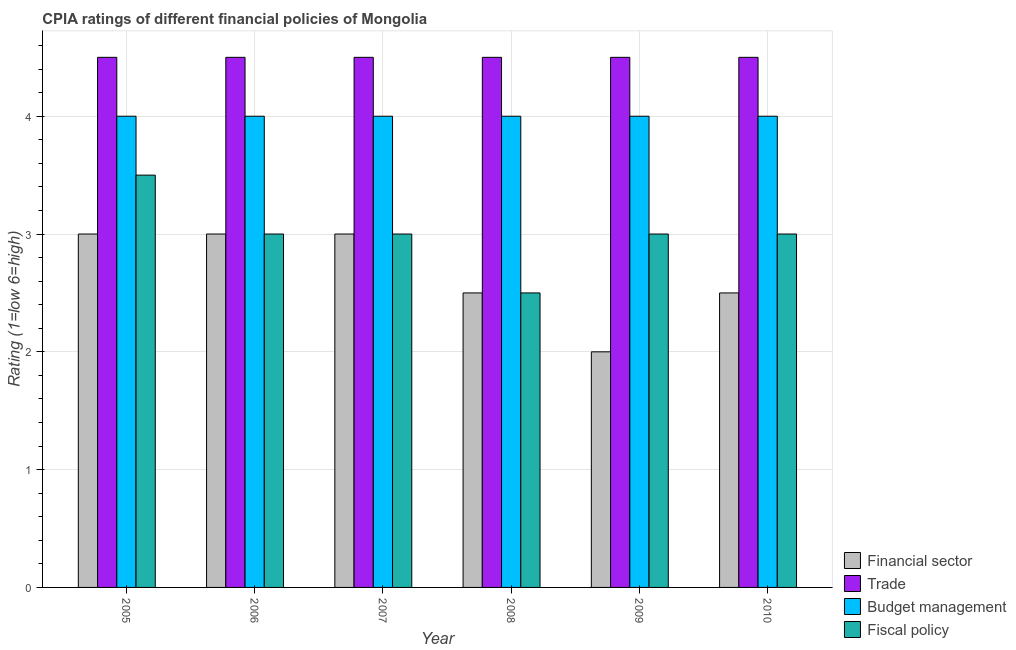How many different coloured bars are there?
Offer a terse response. 4. How many bars are there on the 1st tick from the left?
Give a very brief answer. 4. How many bars are there on the 6th tick from the right?
Offer a very short reply. 4. What is the cpia rating of budget management in 2009?
Ensure brevity in your answer.  4. What is the difference between the cpia rating of budget management in 2010 and the cpia rating of fiscal policy in 2009?
Offer a very short reply. 0. What is the average cpia rating of trade per year?
Your answer should be very brief. 4.5. In the year 2007, what is the difference between the cpia rating of fiscal policy and cpia rating of trade?
Provide a succinct answer. 0. What is the ratio of the cpia rating of fiscal policy in 2005 to that in 2010?
Make the answer very short. 1.17. Is the difference between the cpia rating of financial sector in 2008 and 2010 greater than the difference between the cpia rating of trade in 2008 and 2010?
Make the answer very short. No. In how many years, is the cpia rating of trade greater than the average cpia rating of trade taken over all years?
Your answer should be very brief. 0. Is the sum of the cpia rating of trade in 2007 and 2008 greater than the maximum cpia rating of financial sector across all years?
Ensure brevity in your answer.  Yes. What does the 1st bar from the left in 2005 represents?
Your response must be concise. Financial sector. What does the 3rd bar from the right in 2005 represents?
Provide a succinct answer. Trade. Is it the case that in every year, the sum of the cpia rating of financial sector and cpia rating of trade is greater than the cpia rating of budget management?
Offer a very short reply. Yes. How many bars are there?
Provide a succinct answer. 24. How many years are there in the graph?
Offer a terse response. 6. How many legend labels are there?
Provide a succinct answer. 4. What is the title of the graph?
Make the answer very short. CPIA ratings of different financial policies of Mongolia. What is the label or title of the Y-axis?
Provide a succinct answer. Rating (1=low 6=high). What is the Rating (1=low 6=high) of Financial sector in 2005?
Keep it short and to the point. 3. What is the Rating (1=low 6=high) in Fiscal policy in 2005?
Your response must be concise. 3.5. What is the Rating (1=low 6=high) in Financial sector in 2006?
Your response must be concise. 3. What is the Rating (1=low 6=high) of Trade in 2006?
Make the answer very short. 4.5. What is the Rating (1=low 6=high) in Budget management in 2006?
Your answer should be compact. 4. What is the Rating (1=low 6=high) of Fiscal policy in 2006?
Give a very brief answer. 3. What is the Rating (1=low 6=high) in Financial sector in 2007?
Keep it short and to the point. 3. What is the Rating (1=low 6=high) of Trade in 2007?
Provide a succinct answer. 4.5. What is the Rating (1=low 6=high) of Budget management in 2007?
Your response must be concise. 4. What is the Rating (1=low 6=high) in Trade in 2008?
Provide a short and direct response. 4.5. What is the Rating (1=low 6=high) of Budget management in 2008?
Your answer should be very brief. 4. What is the Rating (1=low 6=high) in Financial sector in 2009?
Keep it short and to the point. 2. What is the Rating (1=low 6=high) of Budget management in 2009?
Provide a succinct answer. 4. What is the Rating (1=low 6=high) of Financial sector in 2010?
Ensure brevity in your answer.  2.5. What is the Rating (1=low 6=high) in Budget management in 2010?
Your answer should be compact. 4. Across all years, what is the maximum Rating (1=low 6=high) in Budget management?
Give a very brief answer. 4. Across all years, what is the maximum Rating (1=low 6=high) of Fiscal policy?
Your response must be concise. 3.5. Across all years, what is the minimum Rating (1=low 6=high) of Trade?
Keep it short and to the point. 4.5. What is the total Rating (1=low 6=high) of Financial sector in the graph?
Your response must be concise. 16. What is the total Rating (1=low 6=high) of Fiscal policy in the graph?
Provide a succinct answer. 18. What is the difference between the Rating (1=low 6=high) in Trade in 2005 and that in 2006?
Ensure brevity in your answer.  0. What is the difference between the Rating (1=low 6=high) of Budget management in 2005 and that in 2006?
Your answer should be compact. 0. What is the difference between the Rating (1=low 6=high) in Financial sector in 2005 and that in 2007?
Your response must be concise. 0. What is the difference between the Rating (1=low 6=high) in Budget management in 2005 and that in 2007?
Give a very brief answer. 0. What is the difference between the Rating (1=low 6=high) of Budget management in 2005 and that in 2008?
Your response must be concise. 0. What is the difference between the Rating (1=low 6=high) in Fiscal policy in 2005 and that in 2008?
Your answer should be compact. 1. What is the difference between the Rating (1=low 6=high) of Financial sector in 2005 and that in 2009?
Offer a terse response. 1. What is the difference between the Rating (1=low 6=high) in Budget management in 2005 and that in 2009?
Your answer should be very brief. 0. What is the difference between the Rating (1=low 6=high) of Fiscal policy in 2005 and that in 2009?
Your response must be concise. 0.5. What is the difference between the Rating (1=low 6=high) in Trade in 2005 and that in 2010?
Offer a very short reply. 0. What is the difference between the Rating (1=low 6=high) of Budget management in 2005 and that in 2010?
Provide a short and direct response. 0. What is the difference between the Rating (1=low 6=high) in Fiscal policy in 2005 and that in 2010?
Ensure brevity in your answer.  0.5. What is the difference between the Rating (1=low 6=high) in Financial sector in 2006 and that in 2007?
Your answer should be very brief. 0. What is the difference between the Rating (1=low 6=high) in Trade in 2006 and that in 2007?
Make the answer very short. 0. What is the difference between the Rating (1=low 6=high) of Budget management in 2006 and that in 2007?
Your response must be concise. 0. What is the difference between the Rating (1=low 6=high) in Fiscal policy in 2006 and that in 2007?
Offer a very short reply. 0. What is the difference between the Rating (1=low 6=high) of Fiscal policy in 2006 and that in 2008?
Offer a very short reply. 0.5. What is the difference between the Rating (1=low 6=high) of Budget management in 2006 and that in 2009?
Your answer should be compact. 0. What is the difference between the Rating (1=low 6=high) of Fiscal policy in 2006 and that in 2009?
Give a very brief answer. 0. What is the difference between the Rating (1=low 6=high) in Financial sector in 2006 and that in 2010?
Offer a terse response. 0.5. What is the difference between the Rating (1=low 6=high) of Trade in 2006 and that in 2010?
Your answer should be compact. 0. What is the difference between the Rating (1=low 6=high) of Fiscal policy in 2006 and that in 2010?
Make the answer very short. 0. What is the difference between the Rating (1=low 6=high) of Trade in 2007 and that in 2008?
Your response must be concise. 0. What is the difference between the Rating (1=low 6=high) of Budget management in 2007 and that in 2008?
Your answer should be very brief. 0. What is the difference between the Rating (1=low 6=high) in Fiscal policy in 2007 and that in 2008?
Provide a short and direct response. 0.5. What is the difference between the Rating (1=low 6=high) in Financial sector in 2007 and that in 2009?
Offer a very short reply. 1. What is the difference between the Rating (1=low 6=high) of Financial sector in 2007 and that in 2010?
Provide a succinct answer. 0.5. What is the difference between the Rating (1=low 6=high) of Trade in 2007 and that in 2010?
Offer a terse response. 0. What is the difference between the Rating (1=low 6=high) in Trade in 2008 and that in 2009?
Provide a short and direct response. 0. What is the difference between the Rating (1=low 6=high) of Fiscal policy in 2008 and that in 2009?
Provide a succinct answer. -0.5. What is the difference between the Rating (1=low 6=high) of Financial sector in 2008 and that in 2010?
Ensure brevity in your answer.  0. What is the difference between the Rating (1=low 6=high) in Trade in 2008 and that in 2010?
Your answer should be very brief. 0. What is the difference between the Rating (1=low 6=high) of Fiscal policy in 2009 and that in 2010?
Your answer should be very brief. 0. What is the difference between the Rating (1=low 6=high) of Financial sector in 2005 and the Rating (1=low 6=high) of Fiscal policy in 2006?
Give a very brief answer. 0. What is the difference between the Rating (1=low 6=high) of Trade in 2005 and the Rating (1=low 6=high) of Budget management in 2006?
Your answer should be compact. 0.5. What is the difference between the Rating (1=low 6=high) in Financial sector in 2005 and the Rating (1=low 6=high) in Trade in 2007?
Ensure brevity in your answer.  -1.5. What is the difference between the Rating (1=low 6=high) of Financial sector in 2005 and the Rating (1=low 6=high) of Fiscal policy in 2007?
Your answer should be very brief. 0. What is the difference between the Rating (1=low 6=high) of Financial sector in 2005 and the Rating (1=low 6=high) of Budget management in 2008?
Your answer should be compact. -1. What is the difference between the Rating (1=low 6=high) of Trade in 2005 and the Rating (1=low 6=high) of Budget management in 2008?
Offer a terse response. 0.5. What is the difference between the Rating (1=low 6=high) in Trade in 2005 and the Rating (1=low 6=high) in Fiscal policy in 2008?
Your answer should be very brief. 2. What is the difference between the Rating (1=low 6=high) in Financial sector in 2005 and the Rating (1=low 6=high) in Fiscal policy in 2009?
Offer a very short reply. 0. What is the difference between the Rating (1=low 6=high) of Trade in 2005 and the Rating (1=low 6=high) of Fiscal policy in 2009?
Offer a very short reply. 1.5. What is the difference between the Rating (1=low 6=high) of Financial sector in 2005 and the Rating (1=low 6=high) of Trade in 2010?
Your answer should be compact. -1.5. What is the difference between the Rating (1=low 6=high) of Financial sector in 2005 and the Rating (1=low 6=high) of Budget management in 2010?
Offer a very short reply. -1. What is the difference between the Rating (1=low 6=high) of Trade in 2005 and the Rating (1=low 6=high) of Budget management in 2010?
Make the answer very short. 0.5. What is the difference between the Rating (1=low 6=high) of Budget management in 2005 and the Rating (1=low 6=high) of Fiscal policy in 2010?
Make the answer very short. 1. What is the difference between the Rating (1=low 6=high) of Financial sector in 2006 and the Rating (1=low 6=high) of Trade in 2007?
Make the answer very short. -1.5. What is the difference between the Rating (1=low 6=high) of Financial sector in 2006 and the Rating (1=low 6=high) of Fiscal policy in 2007?
Make the answer very short. 0. What is the difference between the Rating (1=low 6=high) of Budget management in 2006 and the Rating (1=low 6=high) of Fiscal policy in 2007?
Make the answer very short. 1. What is the difference between the Rating (1=low 6=high) in Financial sector in 2006 and the Rating (1=low 6=high) in Trade in 2008?
Provide a short and direct response. -1.5. What is the difference between the Rating (1=low 6=high) of Financial sector in 2006 and the Rating (1=low 6=high) of Budget management in 2008?
Your answer should be compact. -1. What is the difference between the Rating (1=low 6=high) in Trade in 2006 and the Rating (1=low 6=high) in Budget management in 2008?
Provide a succinct answer. 0.5. What is the difference between the Rating (1=low 6=high) in Budget management in 2006 and the Rating (1=low 6=high) in Fiscal policy in 2008?
Give a very brief answer. 1.5. What is the difference between the Rating (1=low 6=high) of Financial sector in 2006 and the Rating (1=low 6=high) of Trade in 2009?
Offer a terse response. -1.5. What is the difference between the Rating (1=low 6=high) of Financial sector in 2006 and the Rating (1=low 6=high) of Budget management in 2009?
Offer a terse response. -1. What is the difference between the Rating (1=low 6=high) of Financial sector in 2006 and the Rating (1=low 6=high) of Fiscal policy in 2009?
Your answer should be compact. 0. What is the difference between the Rating (1=low 6=high) of Trade in 2006 and the Rating (1=low 6=high) of Fiscal policy in 2009?
Ensure brevity in your answer.  1.5. What is the difference between the Rating (1=low 6=high) of Budget management in 2006 and the Rating (1=low 6=high) of Fiscal policy in 2009?
Keep it short and to the point. 1. What is the difference between the Rating (1=low 6=high) in Financial sector in 2006 and the Rating (1=low 6=high) in Budget management in 2010?
Keep it short and to the point. -1. What is the difference between the Rating (1=low 6=high) of Financial sector in 2006 and the Rating (1=low 6=high) of Fiscal policy in 2010?
Offer a very short reply. 0. What is the difference between the Rating (1=low 6=high) in Trade in 2006 and the Rating (1=low 6=high) in Fiscal policy in 2010?
Keep it short and to the point. 1.5. What is the difference between the Rating (1=low 6=high) in Financial sector in 2007 and the Rating (1=low 6=high) in Fiscal policy in 2008?
Your answer should be very brief. 0.5. What is the difference between the Rating (1=low 6=high) of Budget management in 2007 and the Rating (1=low 6=high) of Fiscal policy in 2008?
Make the answer very short. 1.5. What is the difference between the Rating (1=low 6=high) of Financial sector in 2007 and the Rating (1=low 6=high) of Budget management in 2009?
Make the answer very short. -1. What is the difference between the Rating (1=low 6=high) in Financial sector in 2007 and the Rating (1=low 6=high) in Fiscal policy in 2009?
Your response must be concise. 0. What is the difference between the Rating (1=low 6=high) of Financial sector in 2007 and the Rating (1=low 6=high) of Fiscal policy in 2010?
Give a very brief answer. 0. What is the difference between the Rating (1=low 6=high) of Trade in 2007 and the Rating (1=low 6=high) of Fiscal policy in 2010?
Your answer should be compact. 1.5. What is the difference between the Rating (1=low 6=high) of Financial sector in 2008 and the Rating (1=low 6=high) of Budget management in 2009?
Your response must be concise. -1.5. What is the difference between the Rating (1=low 6=high) in Financial sector in 2008 and the Rating (1=low 6=high) in Fiscal policy in 2009?
Offer a very short reply. -0.5. What is the difference between the Rating (1=low 6=high) of Trade in 2008 and the Rating (1=low 6=high) of Fiscal policy in 2009?
Provide a succinct answer. 1.5. What is the difference between the Rating (1=low 6=high) in Budget management in 2008 and the Rating (1=low 6=high) in Fiscal policy in 2009?
Your answer should be compact. 1. What is the difference between the Rating (1=low 6=high) of Financial sector in 2008 and the Rating (1=low 6=high) of Budget management in 2010?
Offer a terse response. -1.5. What is the difference between the Rating (1=low 6=high) in Financial sector in 2008 and the Rating (1=low 6=high) in Fiscal policy in 2010?
Provide a short and direct response. -0.5. What is the difference between the Rating (1=low 6=high) of Trade in 2008 and the Rating (1=low 6=high) of Budget management in 2010?
Keep it short and to the point. 0.5. What is the difference between the Rating (1=low 6=high) in Trade in 2008 and the Rating (1=low 6=high) in Fiscal policy in 2010?
Ensure brevity in your answer.  1.5. What is the difference between the Rating (1=low 6=high) in Budget management in 2008 and the Rating (1=low 6=high) in Fiscal policy in 2010?
Ensure brevity in your answer.  1. What is the difference between the Rating (1=low 6=high) in Financial sector in 2009 and the Rating (1=low 6=high) in Budget management in 2010?
Your response must be concise. -2. What is the difference between the Rating (1=low 6=high) in Financial sector in 2009 and the Rating (1=low 6=high) in Fiscal policy in 2010?
Provide a short and direct response. -1. What is the difference between the Rating (1=low 6=high) of Budget management in 2009 and the Rating (1=low 6=high) of Fiscal policy in 2010?
Provide a succinct answer. 1. What is the average Rating (1=low 6=high) in Financial sector per year?
Your answer should be very brief. 2.67. What is the average Rating (1=low 6=high) of Budget management per year?
Your response must be concise. 4. In the year 2005, what is the difference between the Rating (1=low 6=high) in Financial sector and Rating (1=low 6=high) in Trade?
Ensure brevity in your answer.  -1.5. In the year 2005, what is the difference between the Rating (1=low 6=high) in Financial sector and Rating (1=low 6=high) in Budget management?
Provide a short and direct response. -1. In the year 2005, what is the difference between the Rating (1=low 6=high) of Financial sector and Rating (1=low 6=high) of Fiscal policy?
Offer a terse response. -0.5. In the year 2006, what is the difference between the Rating (1=low 6=high) of Financial sector and Rating (1=low 6=high) of Trade?
Your answer should be very brief. -1.5. In the year 2006, what is the difference between the Rating (1=low 6=high) in Financial sector and Rating (1=low 6=high) in Budget management?
Provide a succinct answer. -1. In the year 2006, what is the difference between the Rating (1=low 6=high) of Financial sector and Rating (1=low 6=high) of Fiscal policy?
Ensure brevity in your answer.  0. In the year 2006, what is the difference between the Rating (1=low 6=high) in Budget management and Rating (1=low 6=high) in Fiscal policy?
Your response must be concise. 1. In the year 2007, what is the difference between the Rating (1=low 6=high) in Financial sector and Rating (1=low 6=high) in Trade?
Your response must be concise. -1.5. In the year 2007, what is the difference between the Rating (1=low 6=high) of Financial sector and Rating (1=low 6=high) of Budget management?
Give a very brief answer. -1. In the year 2007, what is the difference between the Rating (1=low 6=high) in Financial sector and Rating (1=low 6=high) in Fiscal policy?
Ensure brevity in your answer.  0. In the year 2007, what is the difference between the Rating (1=low 6=high) in Trade and Rating (1=low 6=high) in Fiscal policy?
Your answer should be very brief. 1.5. In the year 2007, what is the difference between the Rating (1=low 6=high) in Budget management and Rating (1=low 6=high) in Fiscal policy?
Provide a succinct answer. 1. In the year 2008, what is the difference between the Rating (1=low 6=high) in Trade and Rating (1=low 6=high) in Fiscal policy?
Provide a short and direct response. 2. In the year 2009, what is the difference between the Rating (1=low 6=high) of Financial sector and Rating (1=low 6=high) of Trade?
Your response must be concise. -2.5. In the year 2009, what is the difference between the Rating (1=low 6=high) in Budget management and Rating (1=low 6=high) in Fiscal policy?
Your answer should be very brief. 1. In the year 2010, what is the difference between the Rating (1=low 6=high) of Financial sector and Rating (1=low 6=high) of Budget management?
Make the answer very short. -1.5. In the year 2010, what is the difference between the Rating (1=low 6=high) of Financial sector and Rating (1=low 6=high) of Fiscal policy?
Provide a short and direct response. -0.5. In the year 2010, what is the difference between the Rating (1=low 6=high) of Trade and Rating (1=low 6=high) of Budget management?
Make the answer very short. 0.5. What is the ratio of the Rating (1=low 6=high) of Financial sector in 2005 to that in 2006?
Your answer should be very brief. 1. What is the ratio of the Rating (1=low 6=high) in Budget management in 2005 to that in 2006?
Ensure brevity in your answer.  1. What is the ratio of the Rating (1=low 6=high) in Fiscal policy in 2005 to that in 2007?
Your answer should be very brief. 1.17. What is the ratio of the Rating (1=low 6=high) of Financial sector in 2005 to that in 2008?
Provide a short and direct response. 1.2. What is the ratio of the Rating (1=low 6=high) in Budget management in 2005 to that in 2008?
Offer a terse response. 1. What is the ratio of the Rating (1=low 6=high) in Budget management in 2005 to that in 2009?
Make the answer very short. 1. What is the ratio of the Rating (1=low 6=high) of Financial sector in 2005 to that in 2010?
Offer a terse response. 1.2. What is the ratio of the Rating (1=low 6=high) of Trade in 2005 to that in 2010?
Give a very brief answer. 1. What is the ratio of the Rating (1=low 6=high) in Fiscal policy in 2005 to that in 2010?
Provide a succinct answer. 1.17. What is the ratio of the Rating (1=low 6=high) of Financial sector in 2006 to that in 2007?
Offer a very short reply. 1. What is the ratio of the Rating (1=low 6=high) of Trade in 2006 to that in 2007?
Make the answer very short. 1. What is the ratio of the Rating (1=low 6=high) in Budget management in 2006 to that in 2007?
Offer a very short reply. 1. What is the ratio of the Rating (1=low 6=high) of Trade in 2006 to that in 2008?
Ensure brevity in your answer.  1. What is the ratio of the Rating (1=low 6=high) of Budget management in 2006 to that in 2008?
Provide a succinct answer. 1. What is the ratio of the Rating (1=low 6=high) in Trade in 2006 to that in 2009?
Give a very brief answer. 1. What is the ratio of the Rating (1=low 6=high) in Financial sector in 2006 to that in 2010?
Ensure brevity in your answer.  1.2. What is the ratio of the Rating (1=low 6=high) in Trade in 2006 to that in 2010?
Offer a terse response. 1. What is the ratio of the Rating (1=low 6=high) in Financial sector in 2007 to that in 2008?
Give a very brief answer. 1.2. What is the ratio of the Rating (1=low 6=high) in Budget management in 2007 to that in 2008?
Keep it short and to the point. 1. What is the ratio of the Rating (1=low 6=high) in Financial sector in 2007 to that in 2009?
Offer a very short reply. 1.5. What is the ratio of the Rating (1=low 6=high) of Financial sector in 2007 to that in 2010?
Give a very brief answer. 1.2. What is the ratio of the Rating (1=low 6=high) in Fiscal policy in 2007 to that in 2010?
Your response must be concise. 1. What is the ratio of the Rating (1=low 6=high) in Financial sector in 2008 to that in 2009?
Offer a very short reply. 1.25. What is the ratio of the Rating (1=low 6=high) in Trade in 2008 to that in 2009?
Ensure brevity in your answer.  1. What is the ratio of the Rating (1=low 6=high) of Fiscal policy in 2008 to that in 2009?
Your answer should be compact. 0.83. What is the ratio of the Rating (1=low 6=high) in Budget management in 2008 to that in 2010?
Keep it short and to the point. 1. What is the ratio of the Rating (1=low 6=high) of Financial sector in 2009 to that in 2010?
Provide a succinct answer. 0.8. What is the difference between the highest and the second highest Rating (1=low 6=high) of Financial sector?
Your response must be concise. 0. What is the difference between the highest and the second highest Rating (1=low 6=high) in Trade?
Provide a succinct answer. 0. What is the difference between the highest and the second highest Rating (1=low 6=high) in Fiscal policy?
Make the answer very short. 0.5. What is the difference between the highest and the lowest Rating (1=low 6=high) in Financial sector?
Ensure brevity in your answer.  1. What is the difference between the highest and the lowest Rating (1=low 6=high) of Trade?
Provide a short and direct response. 0. What is the difference between the highest and the lowest Rating (1=low 6=high) of Budget management?
Make the answer very short. 0. What is the difference between the highest and the lowest Rating (1=low 6=high) of Fiscal policy?
Your answer should be very brief. 1. 